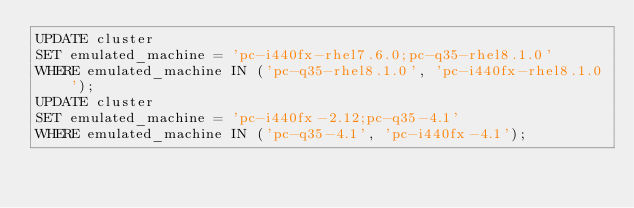<code> <loc_0><loc_0><loc_500><loc_500><_SQL_>UPDATE cluster
SET emulated_machine = 'pc-i440fx-rhel7.6.0;pc-q35-rhel8.1.0'
WHERE emulated_machine IN ('pc-q35-rhel8.1.0', 'pc-i440fx-rhel8.1.0');
UPDATE cluster
SET emulated_machine = 'pc-i440fx-2.12;pc-q35-4.1'
WHERE emulated_machine IN ('pc-q35-4.1', 'pc-i440fx-4.1');
</code> 